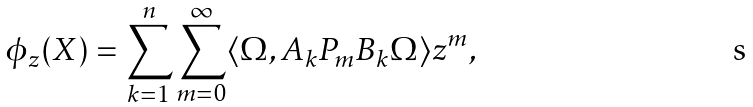Convert formula to latex. <formula><loc_0><loc_0><loc_500><loc_500>\phi _ { z } ( X ) = \sum _ { k = 1 } ^ { n } \sum _ { m = 0 } ^ { \infty } \langle \Omega , A _ { k } P _ { m } B _ { k } \Omega \rangle z ^ { m } ,</formula> 